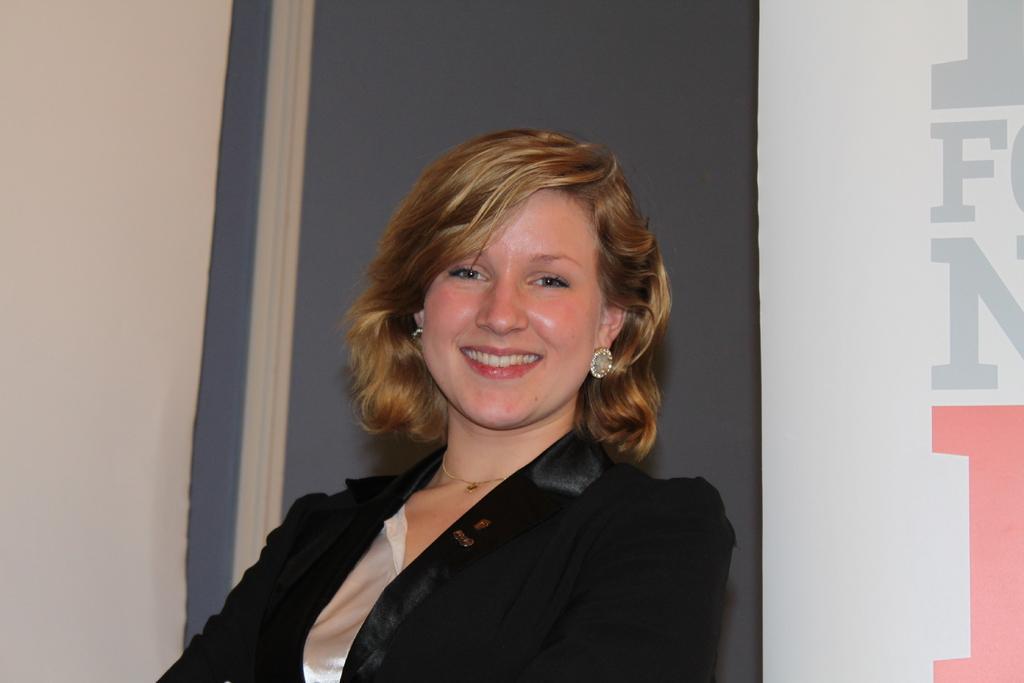Can you describe this image briefly? There is a woman smiling. Background we can see wall and banner. 